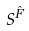Convert formula to latex. <formula><loc_0><loc_0><loc_500><loc_500>S ^ { \hat { F } }</formula> 